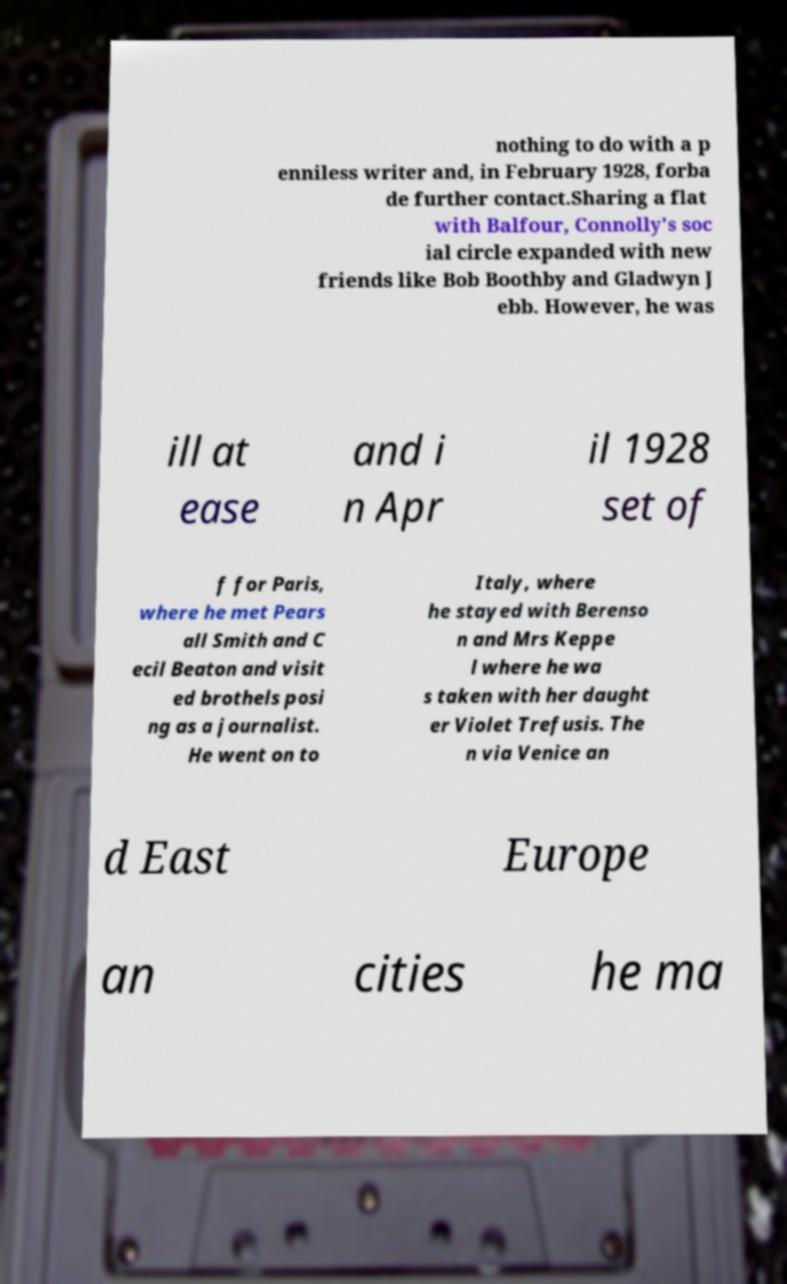Could you assist in decoding the text presented in this image and type it out clearly? nothing to do with a p enniless writer and, in February 1928, forba de further contact.Sharing a flat with Balfour, Connolly's soc ial circle expanded with new friends like Bob Boothby and Gladwyn J ebb. However, he was ill at ease and i n Apr il 1928 set of f for Paris, where he met Pears all Smith and C ecil Beaton and visit ed brothels posi ng as a journalist. He went on to Italy, where he stayed with Berenso n and Mrs Keppe l where he wa s taken with her daught er Violet Trefusis. The n via Venice an d East Europe an cities he ma 